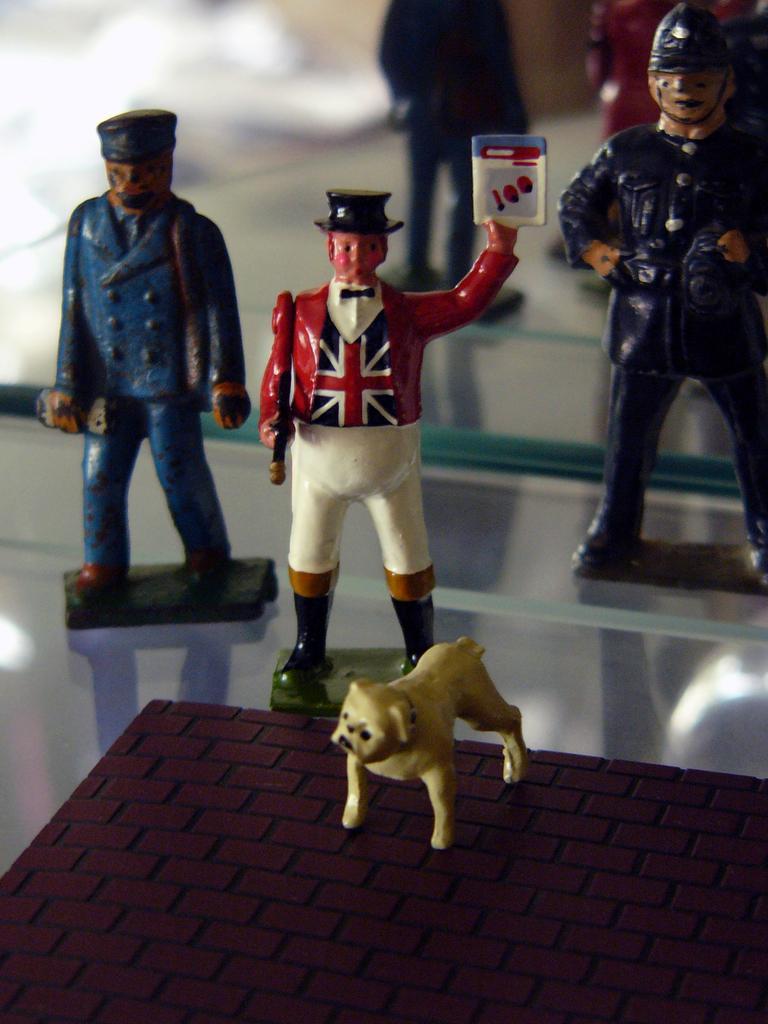Can you describe this image briefly? In this image, we can see human toys are on the glass. Background there is a mirror. Here we can see reflections. At the bottom, we can see brown color object. On top of that there is a dog toy. 